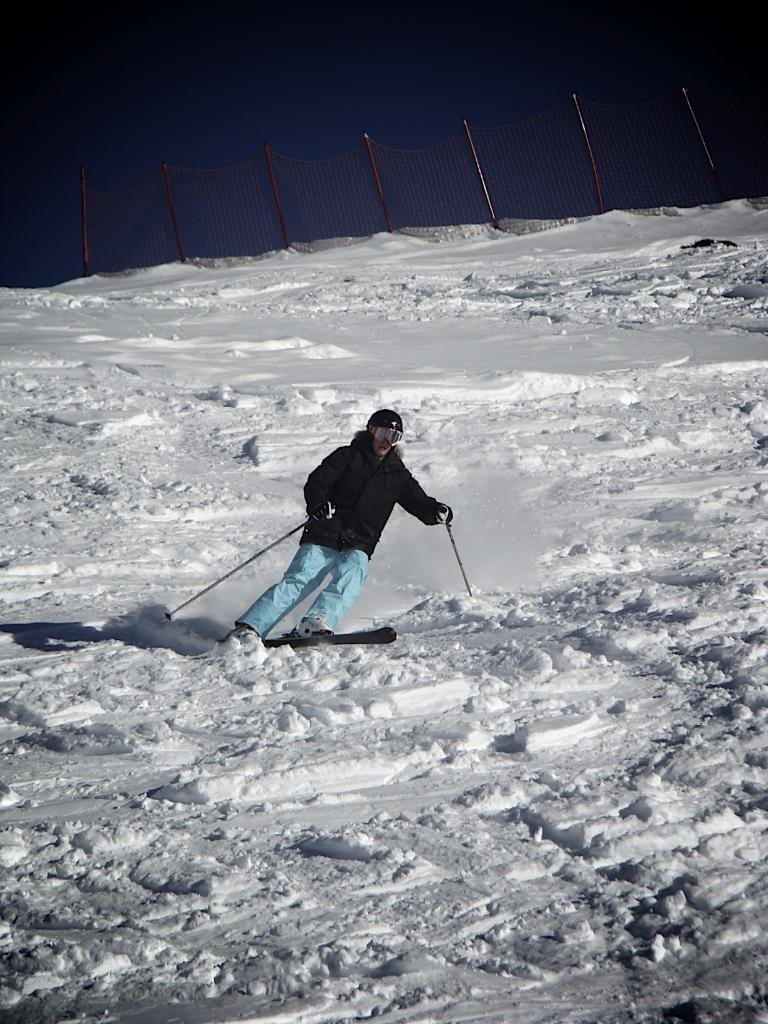Who is present in the image? There is a person in the image. What is the person wearing on their head? The person is wearing a helmet. What is the person holding in their hands? The person is holding sticks. What activity is the person engaged in? The person is skimboarding on the snow floor. What type of impulse is being generated by the person in the image? There is no mention of an impulse being generated by the person in the image. The person is skimboarding, which involves gliding on a board, not generating an impulse. 